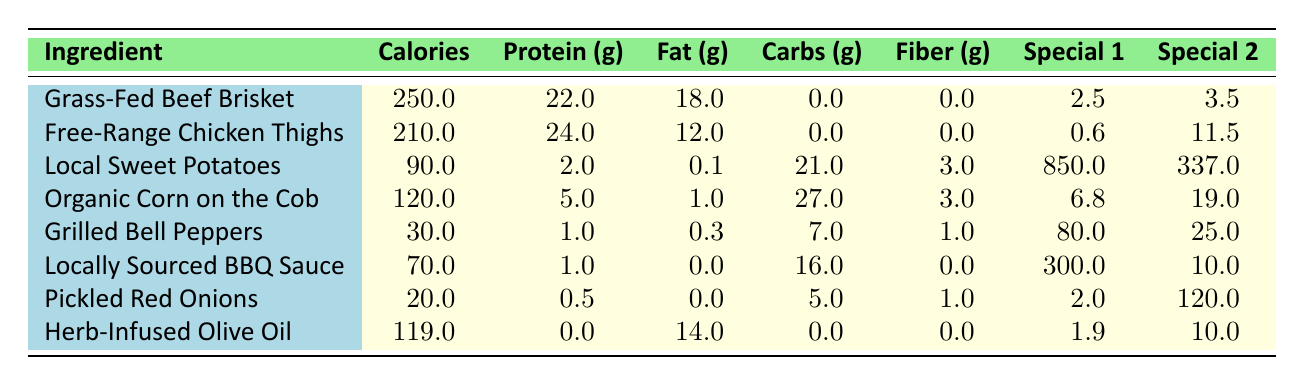What is the calorie content of Grass-Fed Beef Brisket? The table lists the calorie content for Grass-Fed Beef Brisket, which is 250 calories.
Answer: 250 calories Which ingredient has the highest protein content? By reviewing the protein values in the table, Free-Range Chicken Thighs have the highest protein content at 24 grams.
Answer: Free-Range Chicken Thighs What is the total carbohydrate content of Local Sweet Potatoes and Organic Corn on the Cob combined? The carbohydrate content for Local Sweet Potatoes is 21 grams and for Organic Corn on the Cob is 27 grams. Adding these together gives 21 + 27 = 48 grams.
Answer: 48 grams Does Locally Sourced BBQ Sauce contain any fat? The fat content for Locally Sourced BBQ Sauce is listed as 0 grams in the table, indicating it does not contain fat.
Answer: No What is the average calorie content of the ingredients that are not meat-based? The non-meat-based ingredients are Local Sweet Potatoes, Organic Corn on the Cob, Grilled Bell Peppers, Locally Sourced BBQ Sauce, Pickled Red Onions, and Herb-Infused Olive Oil, with calorie contents of 90, 120, 30, 70, 20, and 119 respectively. Summing these gives 90 + 120 + 30 + 70 + 20 + 119 = 449 calories. There are 6 items, so the average is 449 / 6 = 74.83.
Answer: 74.83 calories Which ingredient has the lowest carbohydrate content? By comparing the carbohydrate values listed, Grilled Bell Peppers have the lowest carbohydrate content at 7 grams.
Answer: Grilled Bell Peppers What is the difference in fat content between Grass-Fed Beef Brisket and Free-Range Chicken Thighs? Grass-Fed Beef Brisket has 18 grams of fat while Free-Range Chicken Thighs have 12 grams of fat. The difference is calculated as 18 - 12 = 6 grams.
Answer: 6 grams Is the vitamin content of Local Sweet Potatoes higher than that of Pickled Red Onions? Local Sweet Potatoes have a vitamin A content of 850 mcg, while Pickled Red Onions have a vitamin C content of 2 mg. Since they report different vitamins, the comparison is not straightforward, but focusing on the amounts, 850 mcg is definitively higher than 2 mg.
Answer: Yes What is the sum of the sodium content in Locally Sourced BBQ Sauce and Pickled Red Onions? The sodium content for Locally Sourced BBQ Sauce is 300 mg, and for Pickled Red Onions, it is 120 mg. Adding these gives 300 + 120 = 420 mg.
Answer: 420 mg Which ingredient provides the highest amount of vitamin C? Grilled Bell Peppers have the highest vitamin C content at 80 mg, compared to others in the table.
Answer: Grilled Bell Peppers 